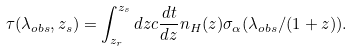Convert formula to latex. <formula><loc_0><loc_0><loc_500><loc_500>\tau ( \lambda _ { o b s } , z _ { s } ) = \int _ { z _ { r } } ^ { z _ { s } } d z c \frac { d t } { d z } n _ { H } ( z ) \sigma _ { \alpha } ( \lambda _ { o b s } / ( 1 + z ) ) .</formula> 